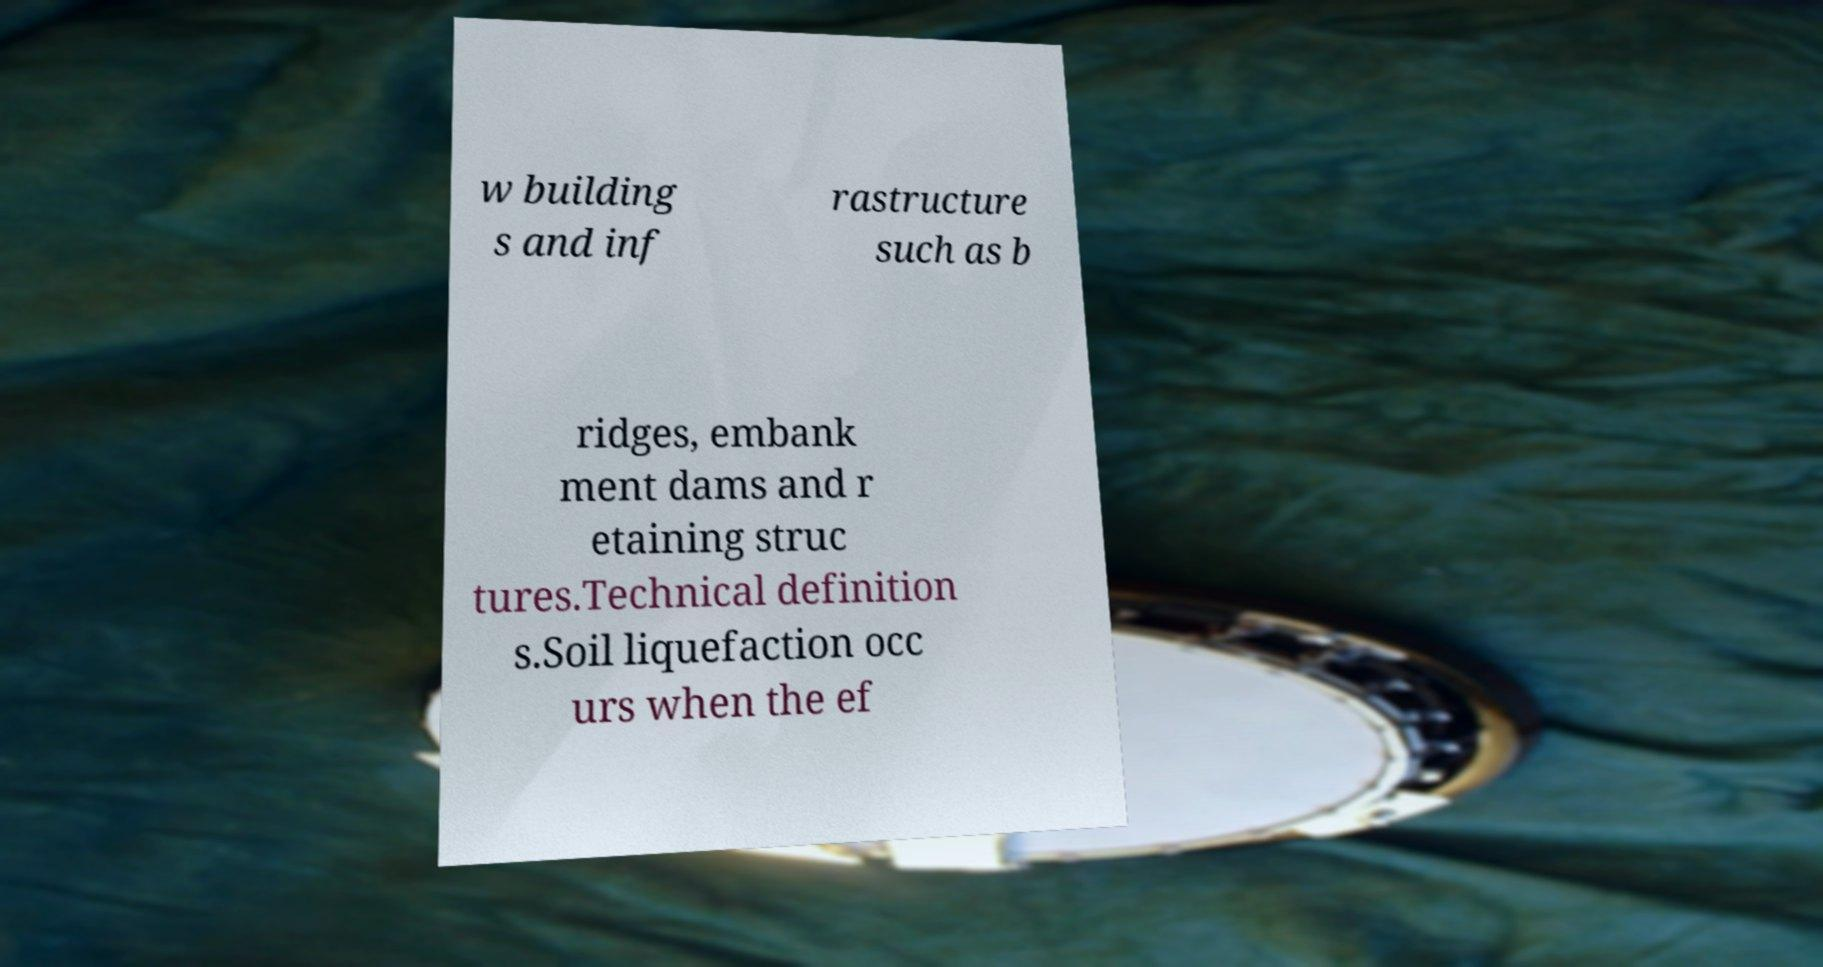Please read and relay the text visible in this image. What does it say? w building s and inf rastructure such as b ridges, embank ment dams and r etaining struc tures.Technical definition s.Soil liquefaction occ urs when the ef 